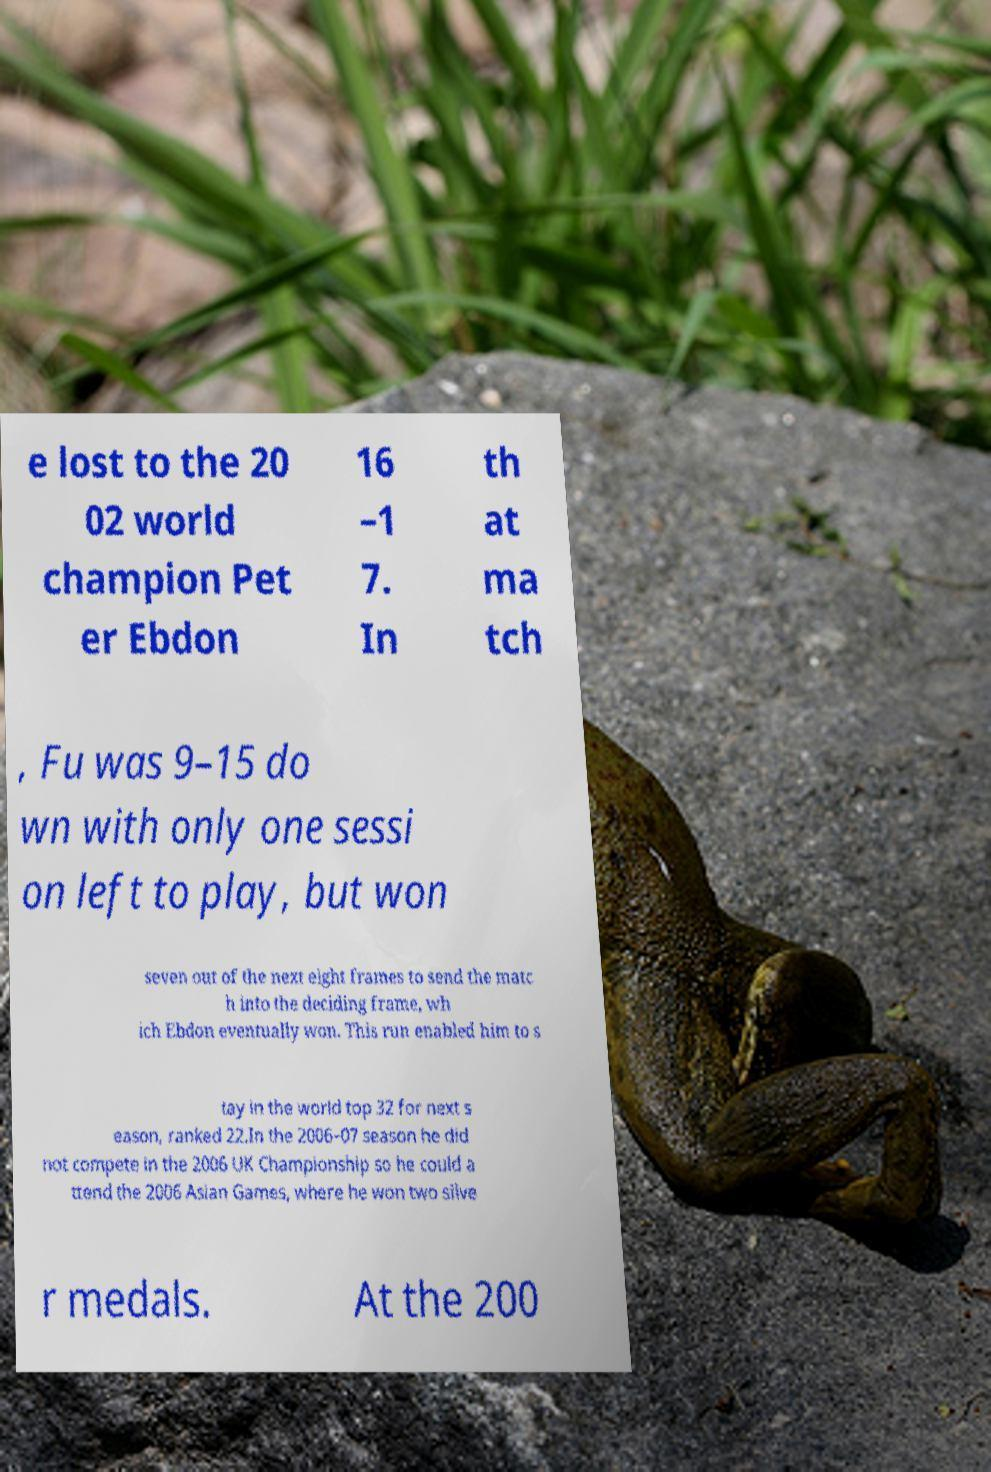Can you read and provide the text displayed in the image?This photo seems to have some interesting text. Can you extract and type it out for me? e lost to the 20 02 world champion Pet er Ebdon 16 –1 7. In th at ma tch , Fu was 9–15 do wn with only one sessi on left to play, but won seven out of the next eight frames to send the matc h into the deciding frame, wh ich Ebdon eventually won. This run enabled him to s tay in the world top 32 for next s eason, ranked 22.In the 2006–07 season he did not compete in the 2006 UK Championship so he could a ttend the 2006 Asian Games, where he won two silve r medals. At the 200 